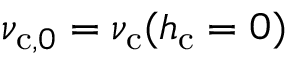<formula> <loc_0><loc_0><loc_500><loc_500>\nu _ { c , 0 } = \nu _ { c } ( h _ { c } = 0 )</formula> 